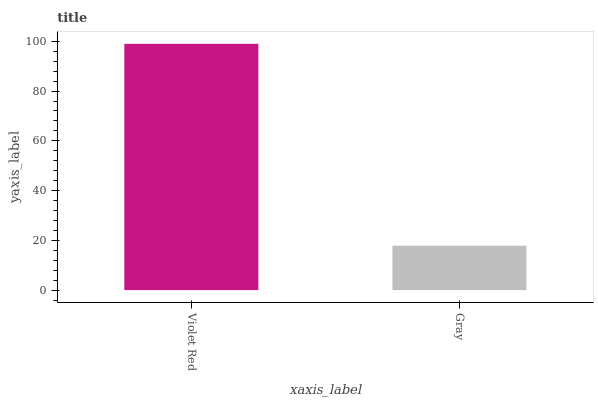Is Gray the minimum?
Answer yes or no. Yes. Is Violet Red the maximum?
Answer yes or no. Yes. Is Gray the maximum?
Answer yes or no. No. Is Violet Red greater than Gray?
Answer yes or no. Yes. Is Gray less than Violet Red?
Answer yes or no. Yes. Is Gray greater than Violet Red?
Answer yes or no. No. Is Violet Red less than Gray?
Answer yes or no. No. Is Violet Red the high median?
Answer yes or no. Yes. Is Gray the low median?
Answer yes or no. Yes. Is Gray the high median?
Answer yes or no. No. Is Violet Red the low median?
Answer yes or no. No. 